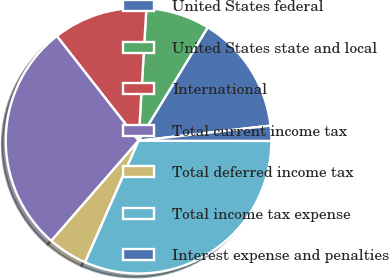<chart> <loc_0><loc_0><loc_500><loc_500><pie_chart><fcel>United States federal<fcel>United States state and local<fcel>International<fcel>Total current income tax<fcel>Total deferred income tax<fcel>Total income tax expense<fcel>Interest expense and penalties<nl><fcel>14.47%<fcel>7.78%<fcel>11.49%<fcel>28.04%<fcel>4.81%<fcel>31.57%<fcel>1.84%<nl></chart> 